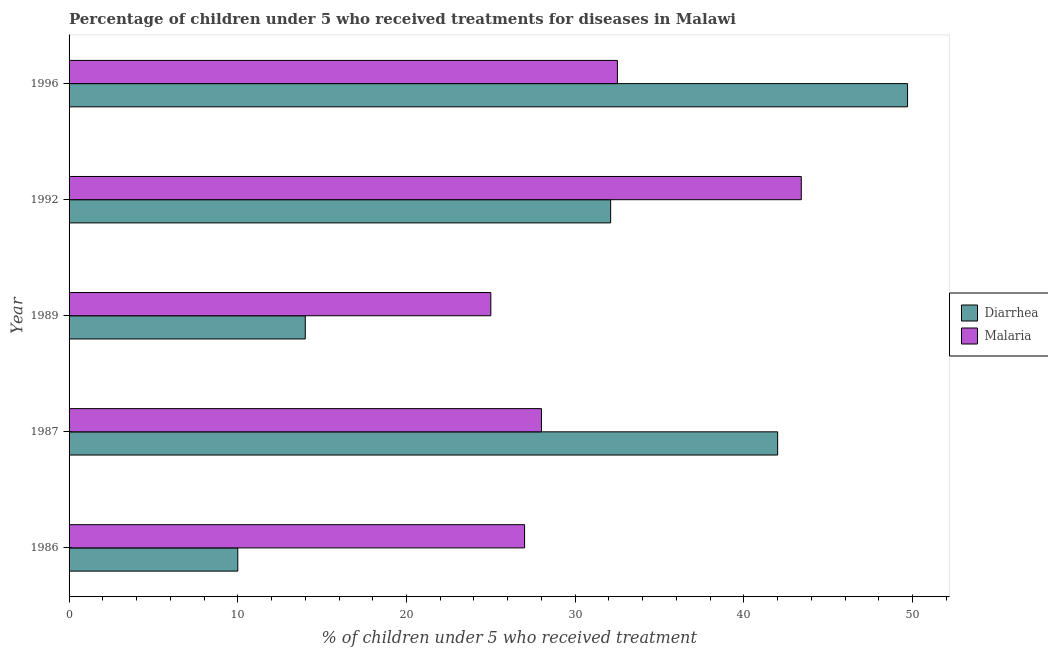How many groups of bars are there?
Provide a short and direct response. 5. Are the number of bars per tick equal to the number of legend labels?
Keep it short and to the point. Yes. How many bars are there on the 4th tick from the bottom?
Offer a terse response. 2. What is the label of the 5th group of bars from the top?
Provide a succinct answer. 1986. In how many cases, is the number of bars for a given year not equal to the number of legend labels?
Provide a succinct answer. 0. Across all years, what is the maximum percentage of children who received treatment for malaria?
Your response must be concise. 43.4. What is the total percentage of children who received treatment for diarrhoea in the graph?
Your answer should be compact. 147.8. What is the difference between the percentage of children who received treatment for malaria in 1986 and that in 1992?
Your response must be concise. -16.4. What is the average percentage of children who received treatment for diarrhoea per year?
Ensure brevity in your answer.  29.56. In the year 1992, what is the difference between the percentage of children who received treatment for diarrhoea and percentage of children who received treatment for malaria?
Offer a very short reply. -11.3. In how many years, is the percentage of children who received treatment for malaria greater than 26 %?
Keep it short and to the point. 4. What is the ratio of the percentage of children who received treatment for diarrhoea in 1989 to that in 1996?
Keep it short and to the point. 0.28. What is the difference between the highest and the second highest percentage of children who received treatment for malaria?
Offer a terse response. 10.9. What is the difference between the highest and the lowest percentage of children who received treatment for malaria?
Provide a succinct answer. 18.4. In how many years, is the percentage of children who received treatment for malaria greater than the average percentage of children who received treatment for malaria taken over all years?
Your answer should be compact. 2. What does the 2nd bar from the top in 1987 represents?
Provide a succinct answer. Diarrhea. What does the 1st bar from the bottom in 1989 represents?
Offer a very short reply. Diarrhea. How many bars are there?
Offer a very short reply. 10. Are the values on the major ticks of X-axis written in scientific E-notation?
Offer a very short reply. No. How many legend labels are there?
Offer a terse response. 2. How are the legend labels stacked?
Provide a succinct answer. Vertical. What is the title of the graph?
Provide a succinct answer. Percentage of children under 5 who received treatments for diseases in Malawi. Does "Goods and services" appear as one of the legend labels in the graph?
Offer a terse response. No. What is the label or title of the X-axis?
Give a very brief answer. % of children under 5 who received treatment. What is the % of children under 5 who received treatment in Malaria in 1986?
Provide a succinct answer. 27. What is the % of children under 5 who received treatment of Diarrhea in 1992?
Give a very brief answer. 32.1. What is the % of children under 5 who received treatment in Malaria in 1992?
Offer a very short reply. 43.4. What is the % of children under 5 who received treatment in Diarrhea in 1996?
Make the answer very short. 49.7. What is the % of children under 5 who received treatment in Malaria in 1996?
Ensure brevity in your answer.  32.5. Across all years, what is the maximum % of children under 5 who received treatment of Diarrhea?
Provide a short and direct response. 49.7. Across all years, what is the maximum % of children under 5 who received treatment in Malaria?
Give a very brief answer. 43.4. Across all years, what is the minimum % of children under 5 who received treatment of Diarrhea?
Offer a very short reply. 10. Across all years, what is the minimum % of children under 5 who received treatment of Malaria?
Offer a very short reply. 25. What is the total % of children under 5 who received treatment of Diarrhea in the graph?
Your response must be concise. 147.8. What is the total % of children under 5 who received treatment of Malaria in the graph?
Give a very brief answer. 155.9. What is the difference between the % of children under 5 who received treatment of Diarrhea in 1986 and that in 1987?
Provide a succinct answer. -32. What is the difference between the % of children under 5 who received treatment of Malaria in 1986 and that in 1987?
Keep it short and to the point. -1. What is the difference between the % of children under 5 who received treatment of Diarrhea in 1986 and that in 1989?
Make the answer very short. -4. What is the difference between the % of children under 5 who received treatment in Malaria in 1986 and that in 1989?
Keep it short and to the point. 2. What is the difference between the % of children under 5 who received treatment in Diarrhea in 1986 and that in 1992?
Your answer should be compact. -22.1. What is the difference between the % of children under 5 who received treatment in Malaria in 1986 and that in 1992?
Your answer should be very brief. -16.4. What is the difference between the % of children under 5 who received treatment of Diarrhea in 1986 and that in 1996?
Make the answer very short. -39.7. What is the difference between the % of children under 5 who received treatment in Malaria in 1987 and that in 1992?
Ensure brevity in your answer.  -15.4. What is the difference between the % of children under 5 who received treatment in Malaria in 1987 and that in 1996?
Provide a succinct answer. -4.5. What is the difference between the % of children under 5 who received treatment of Diarrhea in 1989 and that in 1992?
Keep it short and to the point. -18.1. What is the difference between the % of children under 5 who received treatment of Malaria in 1989 and that in 1992?
Your answer should be very brief. -18.4. What is the difference between the % of children under 5 who received treatment in Diarrhea in 1989 and that in 1996?
Your answer should be very brief. -35.7. What is the difference between the % of children under 5 who received treatment in Diarrhea in 1992 and that in 1996?
Keep it short and to the point. -17.6. What is the difference between the % of children under 5 who received treatment in Malaria in 1992 and that in 1996?
Your answer should be very brief. 10.9. What is the difference between the % of children under 5 who received treatment of Diarrhea in 1986 and the % of children under 5 who received treatment of Malaria in 1987?
Keep it short and to the point. -18. What is the difference between the % of children under 5 who received treatment of Diarrhea in 1986 and the % of children under 5 who received treatment of Malaria in 1989?
Keep it short and to the point. -15. What is the difference between the % of children under 5 who received treatment in Diarrhea in 1986 and the % of children under 5 who received treatment in Malaria in 1992?
Provide a short and direct response. -33.4. What is the difference between the % of children under 5 who received treatment in Diarrhea in 1986 and the % of children under 5 who received treatment in Malaria in 1996?
Your answer should be compact. -22.5. What is the difference between the % of children under 5 who received treatment in Diarrhea in 1987 and the % of children under 5 who received treatment in Malaria in 1992?
Offer a very short reply. -1.4. What is the difference between the % of children under 5 who received treatment in Diarrhea in 1987 and the % of children under 5 who received treatment in Malaria in 1996?
Your response must be concise. 9.5. What is the difference between the % of children under 5 who received treatment in Diarrhea in 1989 and the % of children under 5 who received treatment in Malaria in 1992?
Give a very brief answer. -29.4. What is the difference between the % of children under 5 who received treatment in Diarrhea in 1989 and the % of children under 5 who received treatment in Malaria in 1996?
Offer a very short reply. -18.5. What is the difference between the % of children under 5 who received treatment of Diarrhea in 1992 and the % of children under 5 who received treatment of Malaria in 1996?
Make the answer very short. -0.4. What is the average % of children under 5 who received treatment in Diarrhea per year?
Keep it short and to the point. 29.56. What is the average % of children under 5 who received treatment of Malaria per year?
Provide a succinct answer. 31.18. In the year 1986, what is the difference between the % of children under 5 who received treatment in Diarrhea and % of children under 5 who received treatment in Malaria?
Offer a very short reply. -17. In the year 1989, what is the difference between the % of children under 5 who received treatment in Diarrhea and % of children under 5 who received treatment in Malaria?
Provide a short and direct response. -11. In the year 1996, what is the difference between the % of children under 5 who received treatment of Diarrhea and % of children under 5 who received treatment of Malaria?
Keep it short and to the point. 17.2. What is the ratio of the % of children under 5 who received treatment in Diarrhea in 1986 to that in 1987?
Your answer should be compact. 0.24. What is the ratio of the % of children under 5 who received treatment of Diarrhea in 1986 to that in 1989?
Offer a terse response. 0.71. What is the ratio of the % of children under 5 who received treatment in Diarrhea in 1986 to that in 1992?
Your answer should be compact. 0.31. What is the ratio of the % of children under 5 who received treatment of Malaria in 1986 to that in 1992?
Make the answer very short. 0.62. What is the ratio of the % of children under 5 who received treatment of Diarrhea in 1986 to that in 1996?
Keep it short and to the point. 0.2. What is the ratio of the % of children under 5 who received treatment of Malaria in 1986 to that in 1996?
Provide a succinct answer. 0.83. What is the ratio of the % of children under 5 who received treatment of Diarrhea in 1987 to that in 1989?
Your answer should be very brief. 3. What is the ratio of the % of children under 5 who received treatment of Malaria in 1987 to that in 1989?
Provide a succinct answer. 1.12. What is the ratio of the % of children under 5 who received treatment of Diarrhea in 1987 to that in 1992?
Make the answer very short. 1.31. What is the ratio of the % of children under 5 who received treatment of Malaria in 1987 to that in 1992?
Offer a terse response. 0.65. What is the ratio of the % of children under 5 who received treatment in Diarrhea in 1987 to that in 1996?
Provide a short and direct response. 0.85. What is the ratio of the % of children under 5 who received treatment of Malaria in 1987 to that in 1996?
Make the answer very short. 0.86. What is the ratio of the % of children under 5 who received treatment of Diarrhea in 1989 to that in 1992?
Ensure brevity in your answer.  0.44. What is the ratio of the % of children under 5 who received treatment in Malaria in 1989 to that in 1992?
Provide a succinct answer. 0.58. What is the ratio of the % of children under 5 who received treatment of Diarrhea in 1989 to that in 1996?
Your response must be concise. 0.28. What is the ratio of the % of children under 5 who received treatment in Malaria in 1989 to that in 1996?
Make the answer very short. 0.77. What is the ratio of the % of children under 5 who received treatment of Diarrhea in 1992 to that in 1996?
Give a very brief answer. 0.65. What is the ratio of the % of children under 5 who received treatment of Malaria in 1992 to that in 1996?
Keep it short and to the point. 1.34. What is the difference between the highest and the second highest % of children under 5 who received treatment in Malaria?
Ensure brevity in your answer.  10.9. What is the difference between the highest and the lowest % of children under 5 who received treatment of Diarrhea?
Your answer should be very brief. 39.7. 